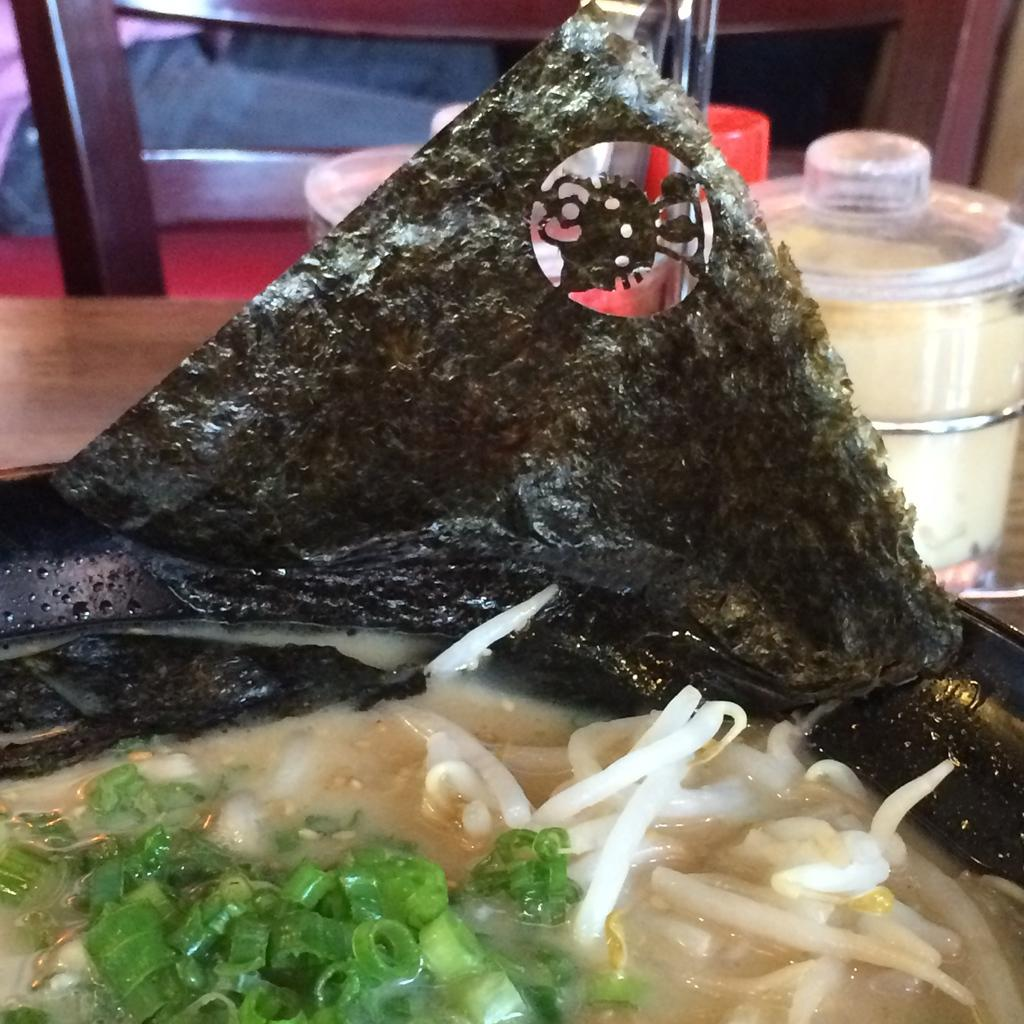What type of food is visible in the image? The facts provided do not specify the type of food in the image. What objects are on the table in the image? There are bowls on the table in the image. Where is the throne located in the image? There is no throne present in the image. How many babies are visible in the image? There is no mention of babies in the image. What color are the toes of the person in the image? There is no person or toes visible in the image. 